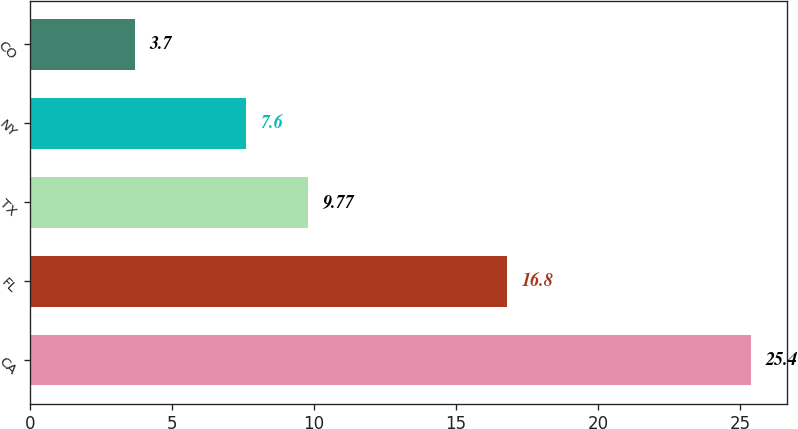Convert chart to OTSL. <chart><loc_0><loc_0><loc_500><loc_500><bar_chart><fcel>CA<fcel>FL<fcel>TX<fcel>NY<fcel>CO<nl><fcel>25.4<fcel>16.8<fcel>9.77<fcel>7.6<fcel>3.7<nl></chart> 